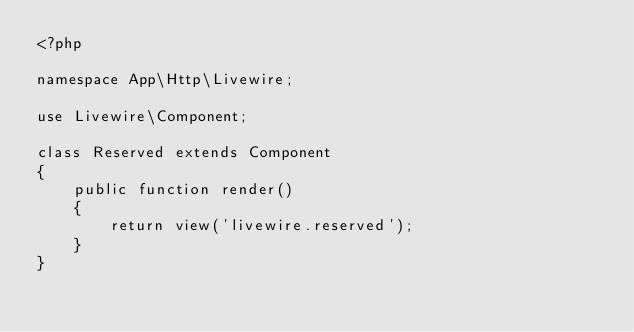<code> <loc_0><loc_0><loc_500><loc_500><_PHP_><?php

namespace App\Http\Livewire;

use Livewire\Component;

class Reserved extends Component
{
    public function render()
    {
        return view('livewire.reserved');
    }
}
</code> 